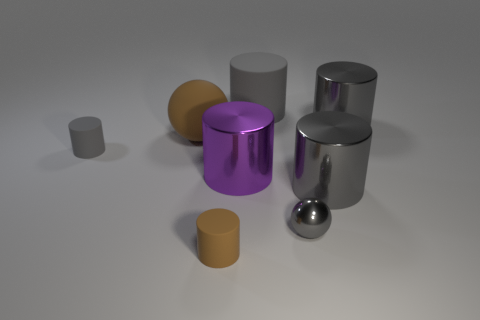Subtract all gray spheres. How many gray cylinders are left? 4 Subtract 2 cylinders. How many cylinders are left? 4 Subtract all big gray metallic cylinders. How many cylinders are left? 4 Subtract all brown cylinders. How many cylinders are left? 5 Add 1 large metal cylinders. How many objects exist? 9 Subtract all blue cylinders. Subtract all yellow blocks. How many cylinders are left? 6 Subtract all balls. How many objects are left? 6 Add 6 large balls. How many large balls are left? 7 Add 7 big shiny things. How many big shiny things exist? 10 Subtract 0 purple balls. How many objects are left? 8 